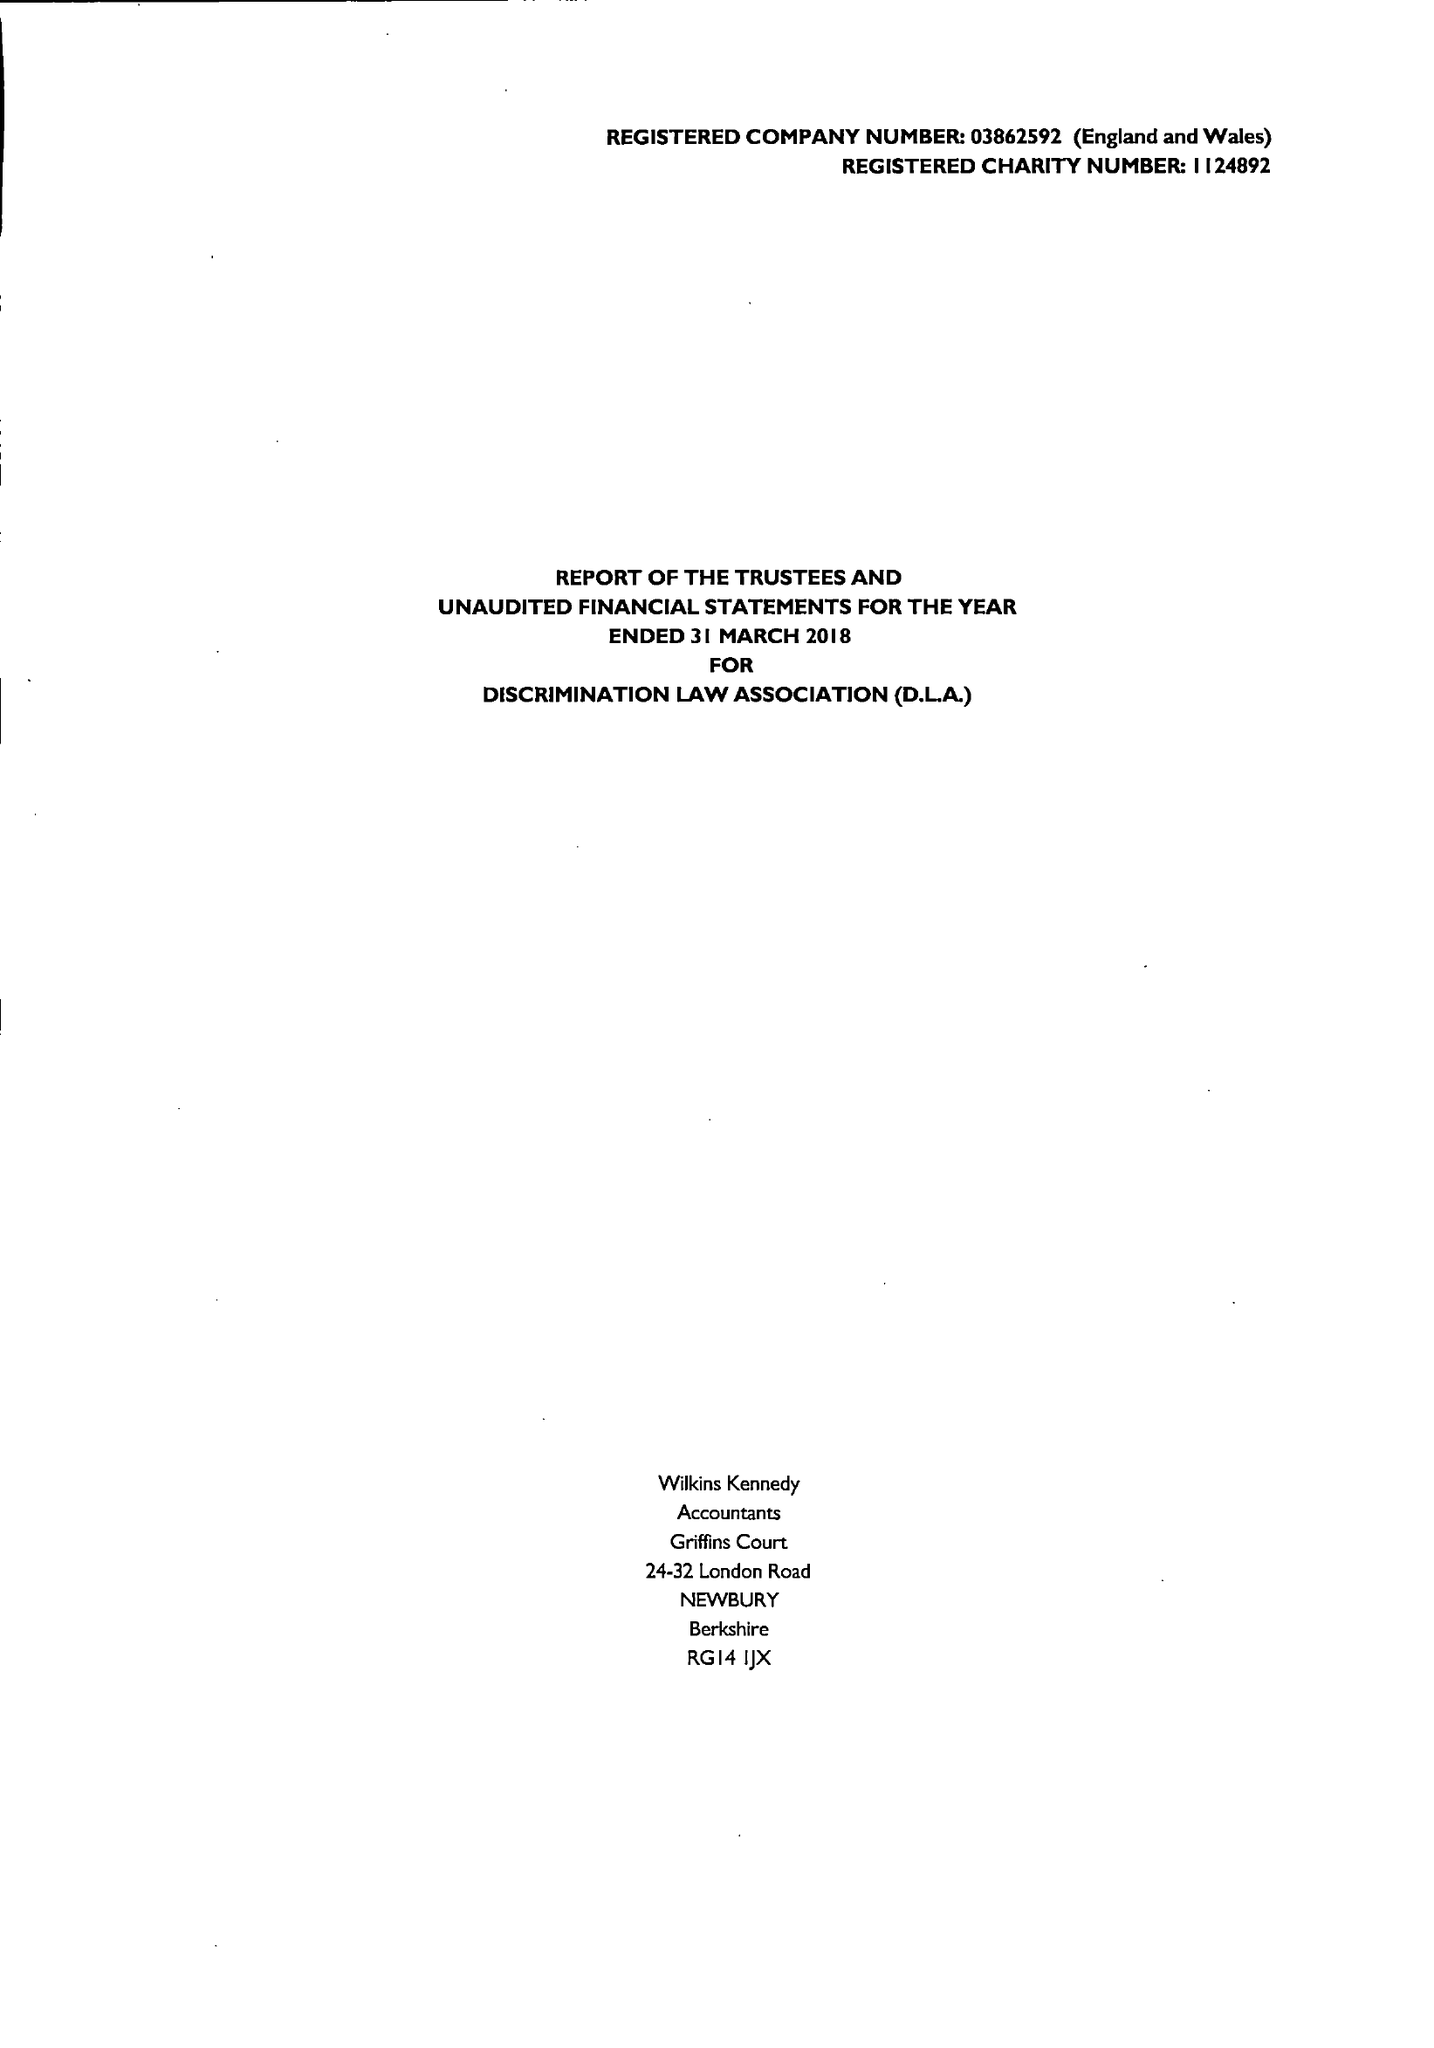What is the value for the charity_number?
Answer the question using a single word or phrase. 1124892 